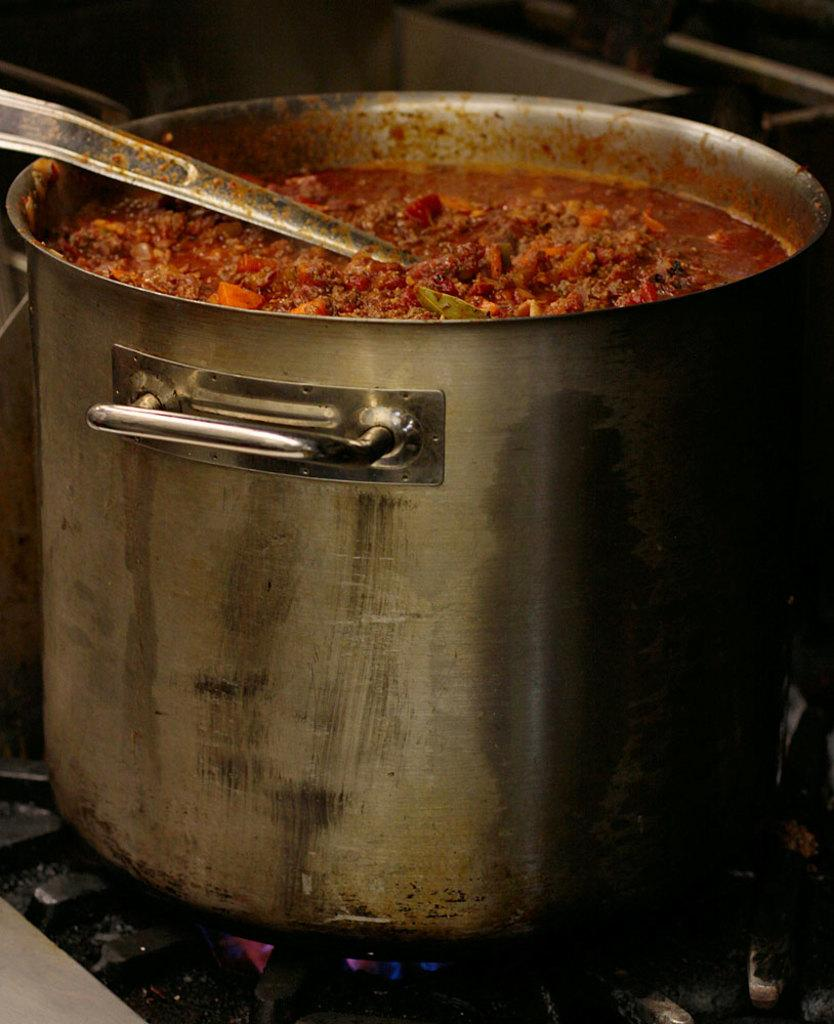What object is on the gas stove in the image? There is a utensil on the gas stove in the image. What is inside the utensil? There is food in the utensil. What is the color of the food? The food is red in color. What utensil is on top of the food? There is a spoon on the food. How does the utensil show respect to the aunt in the image? There is no mention of an aunt or respect in the image; it only shows a utensil with food on a gas stove. 